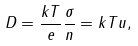<formula> <loc_0><loc_0><loc_500><loc_500>D = \frac { k T } { e } \frac { \sigma } { n } = k T u ,</formula> 